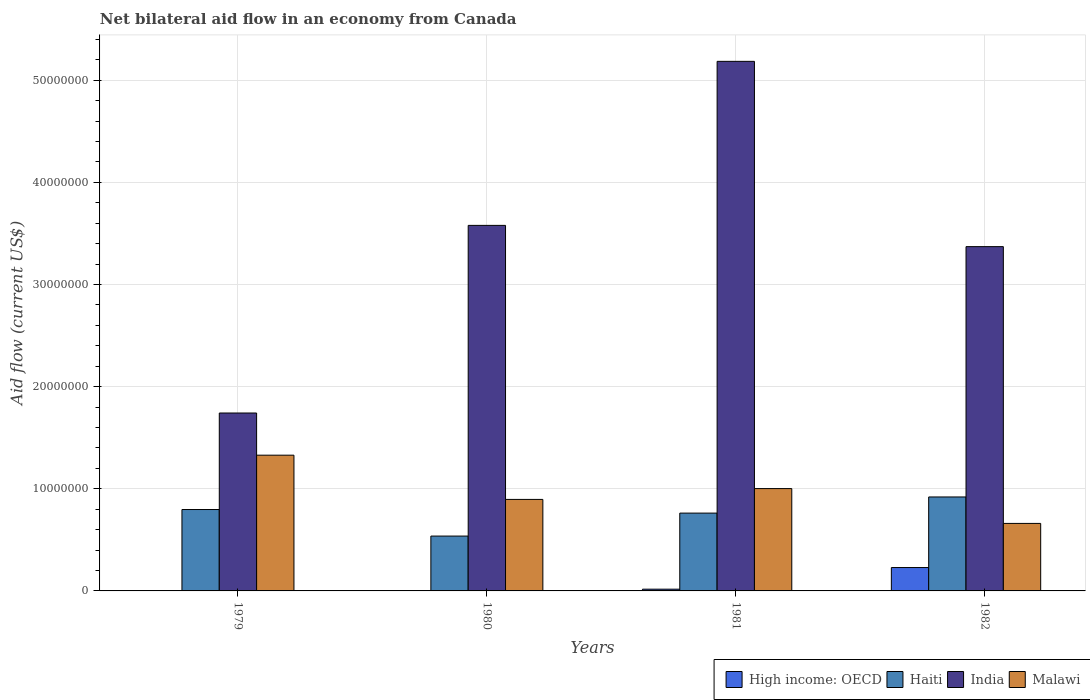How many different coloured bars are there?
Keep it short and to the point. 4. How many bars are there on the 1st tick from the right?
Your response must be concise. 4. What is the label of the 1st group of bars from the left?
Provide a succinct answer. 1979. What is the net bilateral aid flow in Malawi in 1982?
Your response must be concise. 6.61e+06. Across all years, what is the maximum net bilateral aid flow in Haiti?
Give a very brief answer. 9.20e+06. In which year was the net bilateral aid flow in Haiti maximum?
Your response must be concise. 1982. What is the total net bilateral aid flow in High income: OECD in the graph?
Keep it short and to the point. 2.46e+06. What is the difference between the net bilateral aid flow in India in 1980 and that in 1981?
Your response must be concise. -1.61e+07. What is the difference between the net bilateral aid flow in High income: OECD in 1982 and the net bilateral aid flow in Malawi in 1980?
Keep it short and to the point. -6.67e+06. What is the average net bilateral aid flow in Malawi per year?
Offer a terse response. 9.72e+06. In the year 1980, what is the difference between the net bilateral aid flow in Haiti and net bilateral aid flow in Malawi?
Provide a succinct answer. -3.59e+06. In how many years, is the net bilateral aid flow in High income: OECD greater than 10000000 US$?
Ensure brevity in your answer.  0. What is the ratio of the net bilateral aid flow in Haiti in 1979 to that in 1981?
Give a very brief answer. 1.05. Is the difference between the net bilateral aid flow in Haiti in 1981 and 1982 greater than the difference between the net bilateral aid flow in Malawi in 1981 and 1982?
Your answer should be very brief. No. What is the difference between the highest and the second highest net bilateral aid flow in India?
Ensure brevity in your answer.  1.61e+07. What is the difference between the highest and the lowest net bilateral aid flow in Malawi?
Provide a short and direct response. 6.68e+06. Where does the legend appear in the graph?
Your response must be concise. Bottom right. What is the title of the graph?
Your response must be concise. Net bilateral aid flow in an economy from Canada. What is the label or title of the X-axis?
Your answer should be very brief. Years. What is the label or title of the Y-axis?
Offer a very short reply. Aid flow (current US$). What is the Aid flow (current US$) of High income: OECD in 1979?
Your response must be concise. 0. What is the Aid flow (current US$) in Haiti in 1979?
Make the answer very short. 7.97e+06. What is the Aid flow (current US$) in India in 1979?
Provide a succinct answer. 1.74e+07. What is the Aid flow (current US$) of Malawi in 1979?
Provide a succinct answer. 1.33e+07. What is the Aid flow (current US$) of High income: OECD in 1980?
Ensure brevity in your answer.  0. What is the Aid flow (current US$) of Haiti in 1980?
Make the answer very short. 5.37e+06. What is the Aid flow (current US$) in India in 1980?
Provide a succinct answer. 3.58e+07. What is the Aid flow (current US$) in Malawi in 1980?
Your answer should be compact. 8.96e+06. What is the Aid flow (current US$) in Haiti in 1981?
Offer a very short reply. 7.62e+06. What is the Aid flow (current US$) in India in 1981?
Provide a succinct answer. 5.18e+07. What is the Aid flow (current US$) in Malawi in 1981?
Provide a succinct answer. 1.00e+07. What is the Aid flow (current US$) of High income: OECD in 1982?
Keep it short and to the point. 2.29e+06. What is the Aid flow (current US$) of Haiti in 1982?
Make the answer very short. 9.20e+06. What is the Aid flow (current US$) of India in 1982?
Your answer should be very brief. 3.37e+07. What is the Aid flow (current US$) in Malawi in 1982?
Provide a short and direct response. 6.61e+06. Across all years, what is the maximum Aid flow (current US$) in High income: OECD?
Keep it short and to the point. 2.29e+06. Across all years, what is the maximum Aid flow (current US$) of Haiti?
Your response must be concise. 9.20e+06. Across all years, what is the maximum Aid flow (current US$) in India?
Ensure brevity in your answer.  5.18e+07. Across all years, what is the maximum Aid flow (current US$) of Malawi?
Your answer should be very brief. 1.33e+07. Across all years, what is the minimum Aid flow (current US$) of High income: OECD?
Provide a short and direct response. 0. Across all years, what is the minimum Aid flow (current US$) in Haiti?
Offer a very short reply. 5.37e+06. Across all years, what is the minimum Aid flow (current US$) of India?
Your answer should be compact. 1.74e+07. Across all years, what is the minimum Aid flow (current US$) in Malawi?
Your answer should be compact. 6.61e+06. What is the total Aid flow (current US$) of High income: OECD in the graph?
Provide a short and direct response. 2.46e+06. What is the total Aid flow (current US$) of Haiti in the graph?
Provide a short and direct response. 3.02e+07. What is the total Aid flow (current US$) of India in the graph?
Your response must be concise. 1.39e+08. What is the total Aid flow (current US$) in Malawi in the graph?
Provide a short and direct response. 3.89e+07. What is the difference between the Aid flow (current US$) in Haiti in 1979 and that in 1980?
Make the answer very short. 2.60e+06. What is the difference between the Aid flow (current US$) in India in 1979 and that in 1980?
Make the answer very short. -1.84e+07. What is the difference between the Aid flow (current US$) in Malawi in 1979 and that in 1980?
Offer a very short reply. 4.33e+06. What is the difference between the Aid flow (current US$) in Haiti in 1979 and that in 1981?
Offer a very short reply. 3.50e+05. What is the difference between the Aid flow (current US$) of India in 1979 and that in 1981?
Your answer should be very brief. -3.44e+07. What is the difference between the Aid flow (current US$) of Malawi in 1979 and that in 1981?
Provide a succinct answer. 3.27e+06. What is the difference between the Aid flow (current US$) in Haiti in 1979 and that in 1982?
Provide a short and direct response. -1.23e+06. What is the difference between the Aid flow (current US$) in India in 1979 and that in 1982?
Provide a succinct answer. -1.63e+07. What is the difference between the Aid flow (current US$) in Malawi in 1979 and that in 1982?
Ensure brevity in your answer.  6.68e+06. What is the difference between the Aid flow (current US$) in Haiti in 1980 and that in 1981?
Make the answer very short. -2.25e+06. What is the difference between the Aid flow (current US$) in India in 1980 and that in 1981?
Make the answer very short. -1.61e+07. What is the difference between the Aid flow (current US$) of Malawi in 1980 and that in 1981?
Ensure brevity in your answer.  -1.06e+06. What is the difference between the Aid flow (current US$) in Haiti in 1980 and that in 1982?
Provide a short and direct response. -3.83e+06. What is the difference between the Aid flow (current US$) in India in 1980 and that in 1982?
Ensure brevity in your answer.  2.08e+06. What is the difference between the Aid flow (current US$) of Malawi in 1980 and that in 1982?
Your answer should be very brief. 2.35e+06. What is the difference between the Aid flow (current US$) of High income: OECD in 1981 and that in 1982?
Your answer should be compact. -2.12e+06. What is the difference between the Aid flow (current US$) in Haiti in 1981 and that in 1982?
Provide a succinct answer. -1.58e+06. What is the difference between the Aid flow (current US$) of India in 1981 and that in 1982?
Keep it short and to the point. 1.81e+07. What is the difference between the Aid flow (current US$) in Malawi in 1981 and that in 1982?
Ensure brevity in your answer.  3.41e+06. What is the difference between the Aid flow (current US$) of Haiti in 1979 and the Aid flow (current US$) of India in 1980?
Give a very brief answer. -2.78e+07. What is the difference between the Aid flow (current US$) of Haiti in 1979 and the Aid flow (current US$) of Malawi in 1980?
Make the answer very short. -9.90e+05. What is the difference between the Aid flow (current US$) in India in 1979 and the Aid flow (current US$) in Malawi in 1980?
Your response must be concise. 8.46e+06. What is the difference between the Aid flow (current US$) of Haiti in 1979 and the Aid flow (current US$) of India in 1981?
Your answer should be very brief. -4.39e+07. What is the difference between the Aid flow (current US$) in Haiti in 1979 and the Aid flow (current US$) in Malawi in 1981?
Your answer should be compact. -2.05e+06. What is the difference between the Aid flow (current US$) of India in 1979 and the Aid flow (current US$) of Malawi in 1981?
Ensure brevity in your answer.  7.40e+06. What is the difference between the Aid flow (current US$) of Haiti in 1979 and the Aid flow (current US$) of India in 1982?
Your answer should be compact. -2.57e+07. What is the difference between the Aid flow (current US$) in Haiti in 1979 and the Aid flow (current US$) in Malawi in 1982?
Provide a succinct answer. 1.36e+06. What is the difference between the Aid flow (current US$) of India in 1979 and the Aid flow (current US$) of Malawi in 1982?
Keep it short and to the point. 1.08e+07. What is the difference between the Aid flow (current US$) of Haiti in 1980 and the Aid flow (current US$) of India in 1981?
Ensure brevity in your answer.  -4.65e+07. What is the difference between the Aid flow (current US$) in Haiti in 1980 and the Aid flow (current US$) in Malawi in 1981?
Offer a very short reply. -4.65e+06. What is the difference between the Aid flow (current US$) in India in 1980 and the Aid flow (current US$) in Malawi in 1981?
Provide a succinct answer. 2.58e+07. What is the difference between the Aid flow (current US$) in Haiti in 1980 and the Aid flow (current US$) in India in 1982?
Ensure brevity in your answer.  -2.83e+07. What is the difference between the Aid flow (current US$) in Haiti in 1980 and the Aid flow (current US$) in Malawi in 1982?
Your answer should be very brief. -1.24e+06. What is the difference between the Aid flow (current US$) in India in 1980 and the Aid flow (current US$) in Malawi in 1982?
Offer a terse response. 2.92e+07. What is the difference between the Aid flow (current US$) of High income: OECD in 1981 and the Aid flow (current US$) of Haiti in 1982?
Provide a succinct answer. -9.03e+06. What is the difference between the Aid flow (current US$) of High income: OECD in 1981 and the Aid flow (current US$) of India in 1982?
Your response must be concise. -3.35e+07. What is the difference between the Aid flow (current US$) in High income: OECD in 1981 and the Aid flow (current US$) in Malawi in 1982?
Ensure brevity in your answer.  -6.44e+06. What is the difference between the Aid flow (current US$) of Haiti in 1981 and the Aid flow (current US$) of India in 1982?
Make the answer very short. -2.61e+07. What is the difference between the Aid flow (current US$) of Haiti in 1981 and the Aid flow (current US$) of Malawi in 1982?
Your answer should be compact. 1.01e+06. What is the difference between the Aid flow (current US$) of India in 1981 and the Aid flow (current US$) of Malawi in 1982?
Keep it short and to the point. 4.52e+07. What is the average Aid flow (current US$) of High income: OECD per year?
Provide a succinct answer. 6.15e+05. What is the average Aid flow (current US$) of Haiti per year?
Provide a short and direct response. 7.54e+06. What is the average Aid flow (current US$) of India per year?
Give a very brief answer. 3.47e+07. What is the average Aid flow (current US$) in Malawi per year?
Make the answer very short. 9.72e+06. In the year 1979, what is the difference between the Aid flow (current US$) in Haiti and Aid flow (current US$) in India?
Ensure brevity in your answer.  -9.45e+06. In the year 1979, what is the difference between the Aid flow (current US$) in Haiti and Aid flow (current US$) in Malawi?
Make the answer very short. -5.32e+06. In the year 1979, what is the difference between the Aid flow (current US$) of India and Aid flow (current US$) of Malawi?
Ensure brevity in your answer.  4.13e+06. In the year 1980, what is the difference between the Aid flow (current US$) of Haiti and Aid flow (current US$) of India?
Give a very brief answer. -3.04e+07. In the year 1980, what is the difference between the Aid flow (current US$) in Haiti and Aid flow (current US$) in Malawi?
Your response must be concise. -3.59e+06. In the year 1980, what is the difference between the Aid flow (current US$) in India and Aid flow (current US$) in Malawi?
Provide a succinct answer. 2.68e+07. In the year 1981, what is the difference between the Aid flow (current US$) of High income: OECD and Aid flow (current US$) of Haiti?
Keep it short and to the point. -7.45e+06. In the year 1981, what is the difference between the Aid flow (current US$) of High income: OECD and Aid flow (current US$) of India?
Provide a short and direct response. -5.17e+07. In the year 1981, what is the difference between the Aid flow (current US$) of High income: OECD and Aid flow (current US$) of Malawi?
Keep it short and to the point. -9.85e+06. In the year 1981, what is the difference between the Aid flow (current US$) of Haiti and Aid flow (current US$) of India?
Keep it short and to the point. -4.42e+07. In the year 1981, what is the difference between the Aid flow (current US$) in Haiti and Aid flow (current US$) in Malawi?
Provide a short and direct response. -2.40e+06. In the year 1981, what is the difference between the Aid flow (current US$) in India and Aid flow (current US$) in Malawi?
Ensure brevity in your answer.  4.18e+07. In the year 1982, what is the difference between the Aid flow (current US$) of High income: OECD and Aid flow (current US$) of Haiti?
Your response must be concise. -6.91e+06. In the year 1982, what is the difference between the Aid flow (current US$) in High income: OECD and Aid flow (current US$) in India?
Offer a terse response. -3.14e+07. In the year 1982, what is the difference between the Aid flow (current US$) in High income: OECD and Aid flow (current US$) in Malawi?
Give a very brief answer. -4.32e+06. In the year 1982, what is the difference between the Aid flow (current US$) of Haiti and Aid flow (current US$) of India?
Offer a very short reply. -2.45e+07. In the year 1982, what is the difference between the Aid flow (current US$) of Haiti and Aid flow (current US$) of Malawi?
Offer a very short reply. 2.59e+06. In the year 1982, what is the difference between the Aid flow (current US$) in India and Aid flow (current US$) in Malawi?
Keep it short and to the point. 2.71e+07. What is the ratio of the Aid flow (current US$) of Haiti in 1979 to that in 1980?
Give a very brief answer. 1.48. What is the ratio of the Aid flow (current US$) in India in 1979 to that in 1980?
Provide a short and direct response. 0.49. What is the ratio of the Aid flow (current US$) in Malawi in 1979 to that in 1980?
Your answer should be very brief. 1.48. What is the ratio of the Aid flow (current US$) of Haiti in 1979 to that in 1981?
Your response must be concise. 1.05. What is the ratio of the Aid flow (current US$) of India in 1979 to that in 1981?
Ensure brevity in your answer.  0.34. What is the ratio of the Aid flow (current US$) of Malawi in 1979 to that in 1981?
Ensure brevity in your answer.  1.33. What is the ratio of the Aid flow (current US$) of Haiti in 1979 to that in 1982?
Keep it short and to the point. 0.87. What is the ratio of the Aid flow (current US$) of India in 1979 to that in 1982?
Your answer should be very brief. 0.52. What is the ratio of the Aid flow (current US$) in Malawi in 1979 to that in 1982?
Provide a succinct answer. 2.01. What is the ratio of the Aid flow (current US$) of Haiti in 1980 to that in 1981?
Ensure brevity in your answer.  0.7. What is the ratio of the Aid flow (current US$) in India in 1980 to that in 1981?
Offer a terse response. 0.69. What is the ratio of the Aid flow (current US$) in Malawi in 1980 to that in 1981?
Provide a short and direct response. 0.89. What is the ratio of the Aid flow (current US$) in Haiti in 1980 to that in 1982?
Offer a very short reply. 0.58. What is the ratio of the Aid flow (current US$) in India in 1980 to that in 1982?
Your answer should be very brief. 1.06. What is the ratio of the Aid flow (current US$) in Malawi in 1980 to that in 1982?
Your answer should be very brief. 1.36. What is the ratio of the Aid flow (current US$) in High income: OECD in 1981 to that in 1982?
Your answer should be compact. 0.07. What is the ratio of the Aid flow (current US$) of Haiti in 1981 to that in 1982?
Your answer should be very brief. 0.83. What is the ratio of the Aid flow (current US$) of India in 1981 to that in 1982?
Provide a succinct answer. 1.54. What is the ratio of the Aid flow (current US$) of Malawi in 1981 to that in 1982?
Offer a terse response. 1.52. What is the difference between the highest and the second highest Aid flow (current US$) in Haiti?
Your answer should be very brief. 1.23e+06. What is the difference between the highest and the second highest Aid flow (current US$) of India?
Provide a short and direct response. 1.61e+07. What is the difference between the highest and the second highest Aid flow (current US$) of Malawi?
Ensure brevity in your answer.  3.27e+06. What is the difference between the highest and the lowest Aid flow (current US$) of High income: OECD?
Give a very brief answer. 2.29e+06. What is the difference between the highest and the lowest Aid flow (current US$) of Haiti?
Offer a very short reply. 3.83e+06. What is the difference between the highest and the lowest Aid flow (current US$) in India?
Provide a short and direct response. 3.44e+07. What is the difference between the highest and the lowest Aid flow (current US$) in Malawi?
Ensure brevity in your answer.  6.68e+06. 